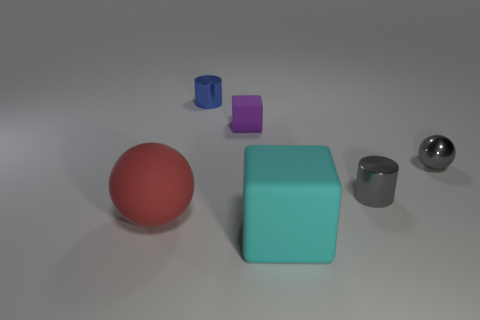Add 3 red matte objects. How many objects exist? 9 Subtract all balls. How many objects are left? 4 Add 6 small metal cylinders. How many small metal cylinders are left? 8 Add 4 small metallic spheres. How many small metallic spheres exist? 5 Subtract 1 gray cylinders. How many objects are left? 5 Subtract all large brown shiny things. Subtract all spheres. How many objects are left? 4 